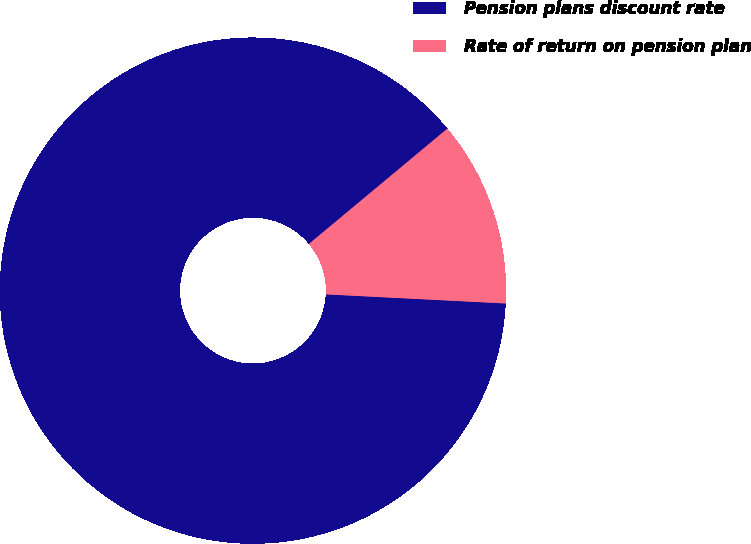<chart> <loc_0><loc_0><loc_500><loc_500><pie_chart><fcel>Pension plans discount rate<fcel>Rate of return on pension plan<nl><fcel>88.14%<fcel>11.86%<nl></chart> 